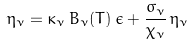Convert formula to latex. <formula><loc_0><loc_0><loc_500><loc_500>\eta _ { \nu } = \kappa _ { \nu } \, B _ { \nu } ( T ) \, \epsilon + \frac { \sigma _ { \nu } } { \chi _ { \nu } } \, \eta _ { \nu }</formula> 